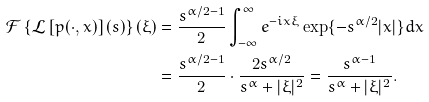Convert formula to latex. <formula><loc_0><loc_0><loc_500><loc_500>\mathcal { F } \left \{ \mathcal { L } \left [ p ( \cdot , x ) \right ] ( s ) \right \} ( \xi ) & = \frac { s ^ { \alpha / 2 - 1 } } { 2 } \int _ { - \infty } ^ { \infty } e ^ { - i x \xi } \exp \{ - s ^ { \alpha / 2 } | x | \} d x \\ & = \frac { s ^ { \alpha / 2 - 1 } } { 2 } \cdot \frac { 2 s ^ { \alpha / 2 } } { s ^ { \alpha } + | \xi | ^ { 2 } } = \frac { s ^ { \alpha - 1 } } { s ^ { \alpha } + | \xi | ^ { 2 } } .</formula> 